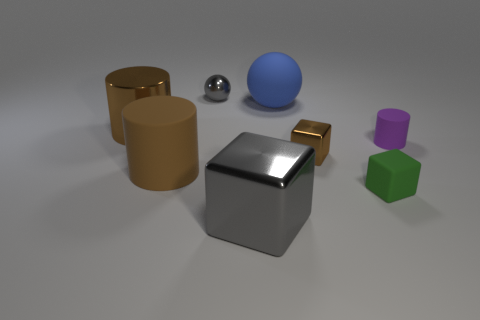Subtract all brown blocks. How many brown cylinders are left? 2 Add 1 red matte cylinders. How many objects exist? 9 Subtract all small blocks. How many blocks are left? 1 Subtract all cubes. How many objects are left? 5 Add 2 small matte objects. How many small matte objects exist? 4 Subtract 1 green blocks. How many objects are left? 7 Subtract all blue cylinders. Subtract all yellow spheres. How many cylinders are left? 3 Subtract all brown matte objects. Subtract all brown metal cubes. How many objects are left? 6 Add 2 small brown metallic cubes. How many small brown metallic cubes are left? 3 